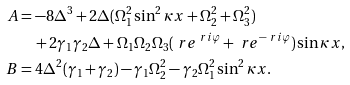Convert formula to latex. <formula><loc_0><loc_0><loc_500><loc_500>A & = - 8 \Delta ^ { 3 } + 2 \Delta ( \Omega _ { 1 } ^ { 2 } \sin ^ { 2 } \kappa x + \Omega _ { 2 } ^ { 2 } + \Omega _ { 3 } ^ { 2 } ) \\ & \quad + 2 \gamma _ { 1 } \gamma _ { 2 } \Delta + \Omega _ { 1 } \Omega _ { 2 } \Omega _ { 3 } ( \ r e ^ { \ r i \varphi } + \ r e ^ { - \ r i \varphi } ) \sin \kappa x , \\ B & = 4 \Delta ^ { 2 } ( \gamma _ { 1 } + \gamma _ { 2 } ) - \gamma _ { 1 } \Omega _ { 2 } ^ { 2 } - \gamma _ { 2 } \Omega _ { 1 } ^ { 2 } \sin ^ { 2 } \kappa x .</formula> 